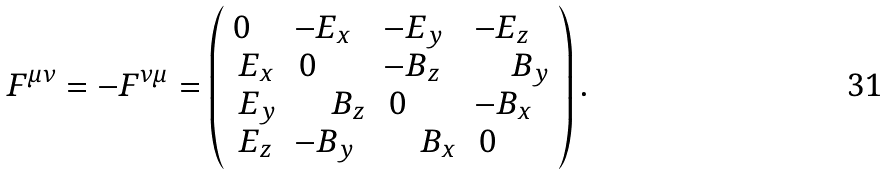<formula> <loc_0><loc_0><loc_500><loc_500>F ^ { \mu \nu } = - F ^ { \nu \mu } = \left ( \begin{array} { l l l l } { 0 } & { { - E _ { x } } } & { { - E _ { y } } } & { { - E _ { z } } } \\ { { \, E _ { x } } } & { \, 0 } & { { - B _ { z } } } & { { \quad \, B _ { y } } } \\ { { \, E _ { y } } } & { { \quad \, B _ { z } } } & { \, 0 } & { { - B _ { x } } } \\ { { \, E _ { z } } } & { { - B _ { y } } } & { { \quad \, B _ { x } } } & { \, 0 } \end{array} \right ) .</formula> 